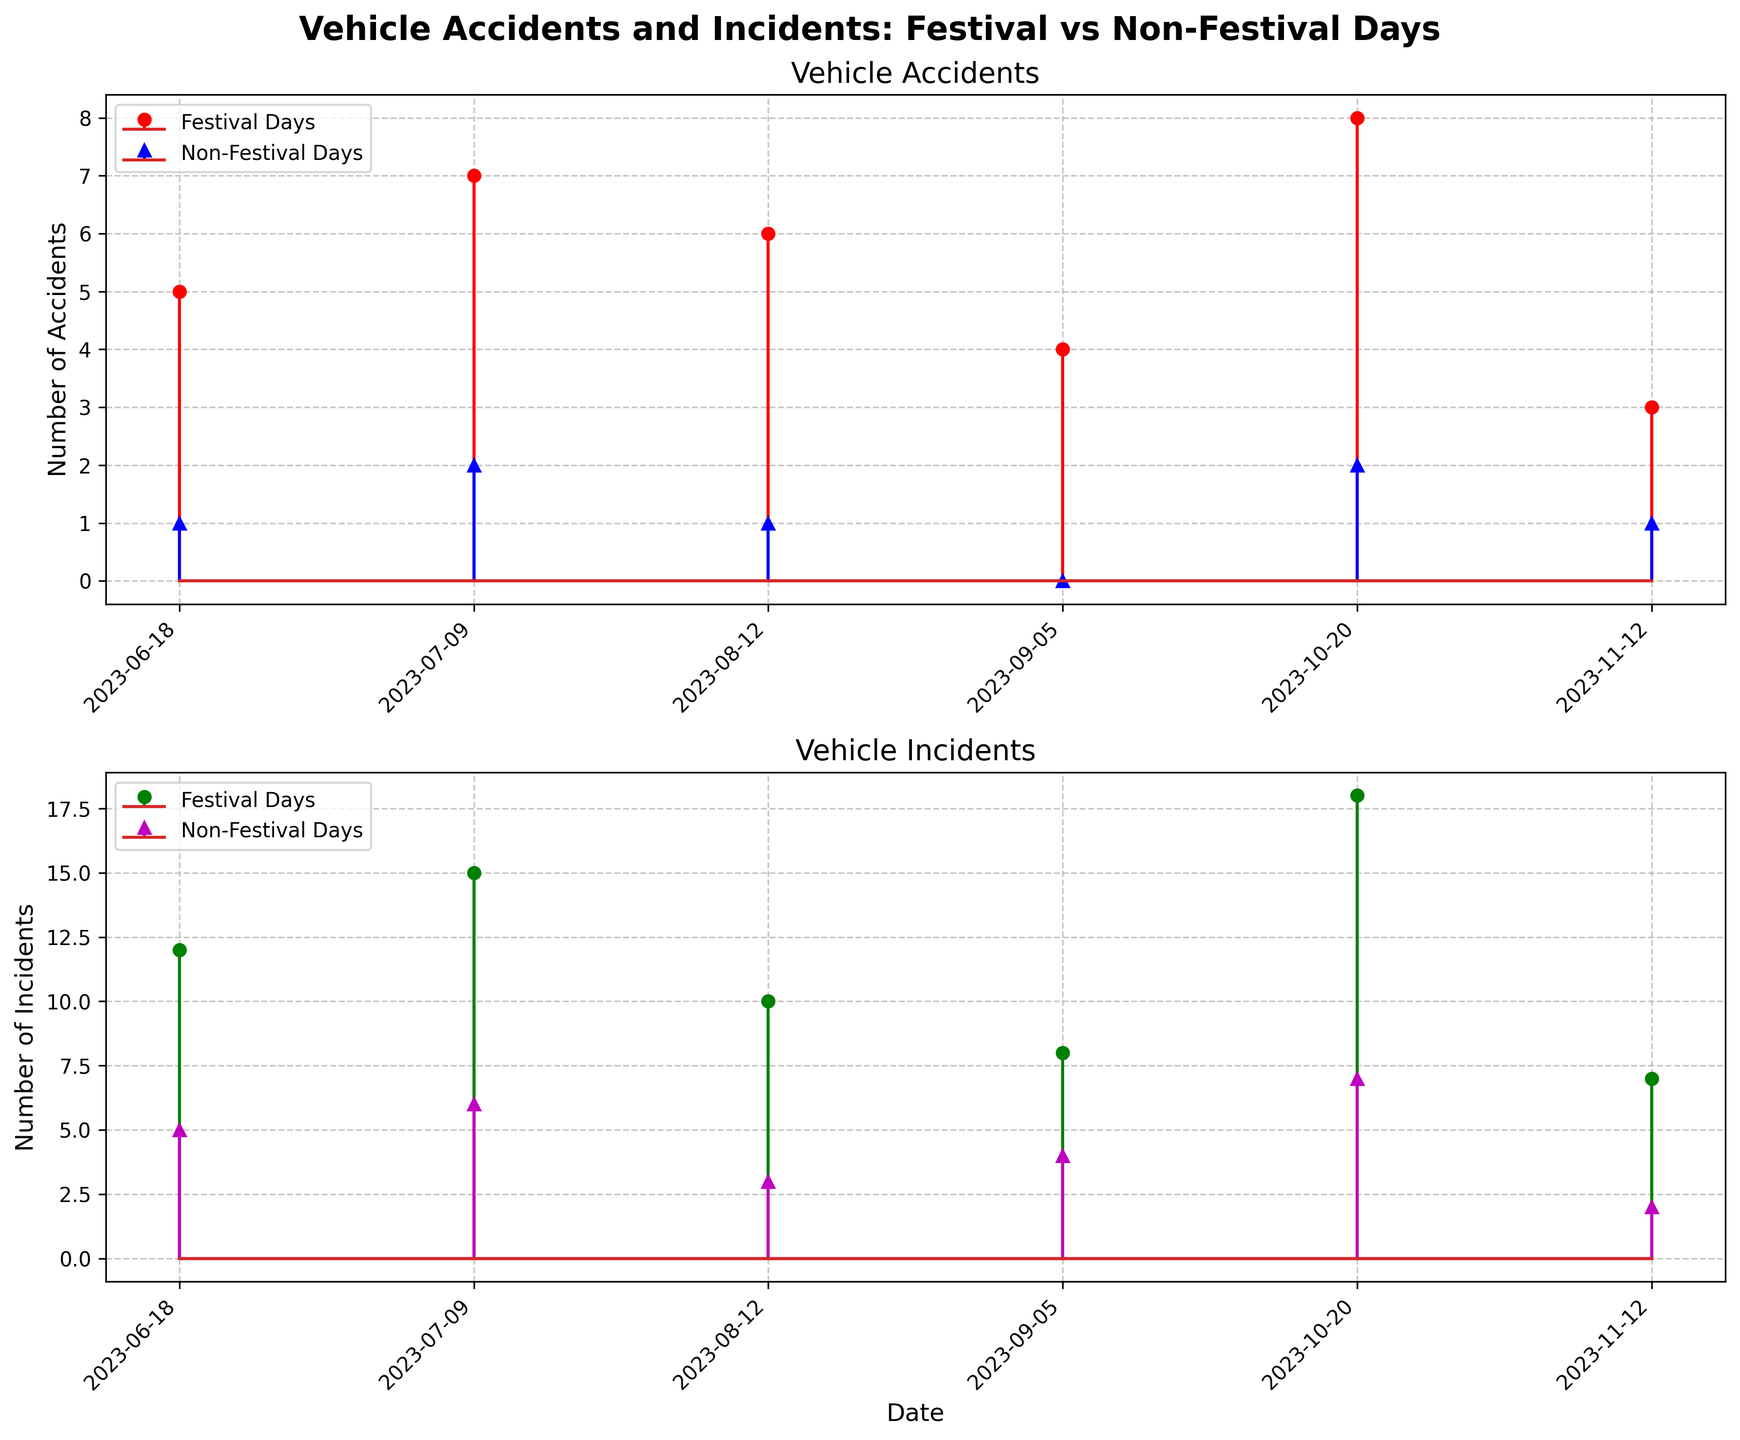What are the titles of the two subplots? The titles of the two subplots are displayed prominently at the top of each subplot. By looking at the figure, you can see the first subplot is titled "Vehicle Accidents" and the second subplot is titled "Vehicle Incidents".
Answer: Vehicle Accidents; Vehicle Incidents Which day recorded the highest number of vehicle accidents during festival days? To answer this, look at the first subplot and scan the red points representing vehicle accidents on festival days. The highest red point is on 2023-10-20, which corresponds to 8 vehicle accidents.
Answer: 2023-10-20 How many vehicle incidents were reported on 2023-07-09 on non-festival days? Look at the second subplot and find the purple marker for 2023-07-09, which indicates vehicle incidents on non-festival days. The purple marker on this date corresponds to 6 incidents.
Answer: 6 What is the total number of vehicle accidents on non-festival days across all locations? To calculate this, sum up all the blue ^ markers in the first subplot, which represents vehicle accidents on non-festival days: 1 + 2 + 1 + 0 + 2 + 1 = 7.
Answer: 7 Compare the number of vehicle incidents on 2023-06-18 between festival and non-festival days. Look at the green and purple markers on the second subplot corresponding to 2023-06-18. The green marker (festival days) shows 12 incidents, and the purple marker (non-festival days) shows 5 incidents.
Answer: Festival days have 7 more incidents than non-festival days Are there more vehicle accidents or incidents on festival days at Riverbend Park on 2023-07-09? We need to compare the values for Riverbend Park on 2023-07-09 in both subplots. From the first subplot, vehicle accidents are 7. From the second subplot, vehicle incidents are 15. Therefore, there are more vehicle incidents than accidents.
Answer: Vehicle incidents Which location had zero vehicle accidents on non-festival days? By looking at the blue ^ markers in the first subplot, we can identify that 2023-09-05 (Green Valley) had a value of 0 accidents.
Answer: Green Valley What is the average number of vehicle incidents on festival days across all dates? To find this, sum up all the green markers indicating vehicle incidents on festival days on the second subplot: 12 + 15 + 10 + 8 + 18 + 7 = 70. Divide by the number of dates (6): 70 / 6 ≈ 11.67.
Answer: 11.67 